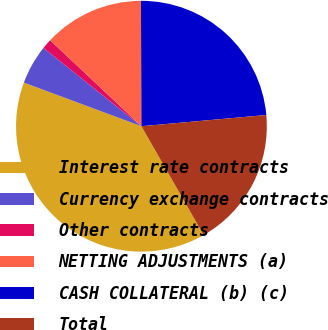Convert chart to OTSL. <chart><loc_0><loc_0><loc_500><loc_500><pie_chart><fcel>Interest rate contracts<fcel>Currency exchange contracts<fcel>Other contracts<fcel>NETTING ADJUSTMENTS (a)<fcel>CASH COLLATERAL (b) (c)<fcel>Total<nl><fcel>38.92%<fcel>5.07%<fcel>1.3%<fcel>12.91%<fcel>23.63%<fcel>18.16%<nl></chart> 